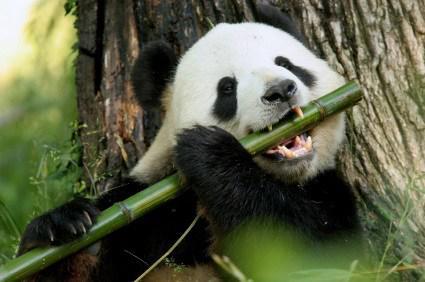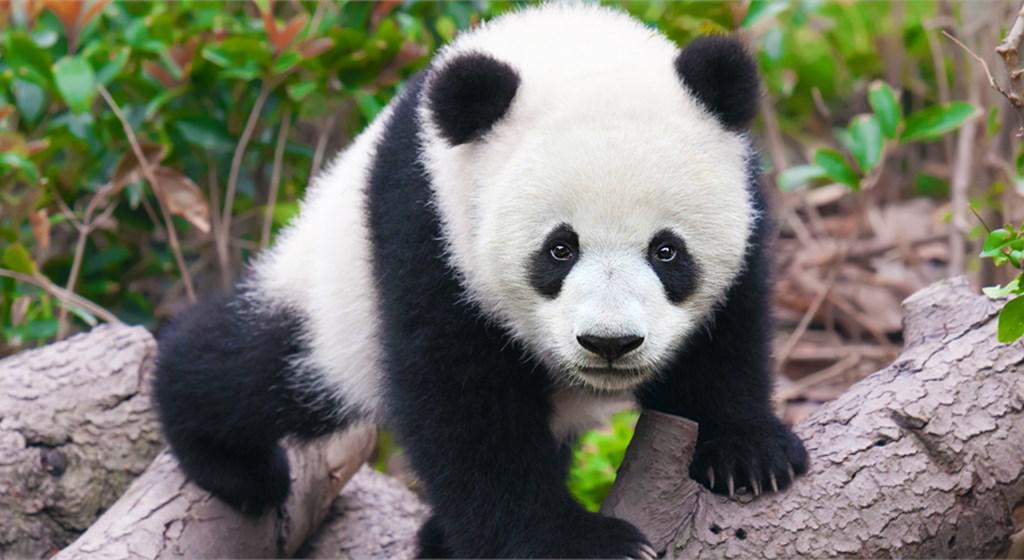The first image is the image on the left, the second image is the image on the right. For the images displayed, is the sentence "a panda is eating bamboo" factually correct? Answer yes or no. Yes. The first image is the image on the left, the second image is the image on the right. For the images shown, is this caption "One panda is eating bamboo." true? Answer yes or no. Yes. 